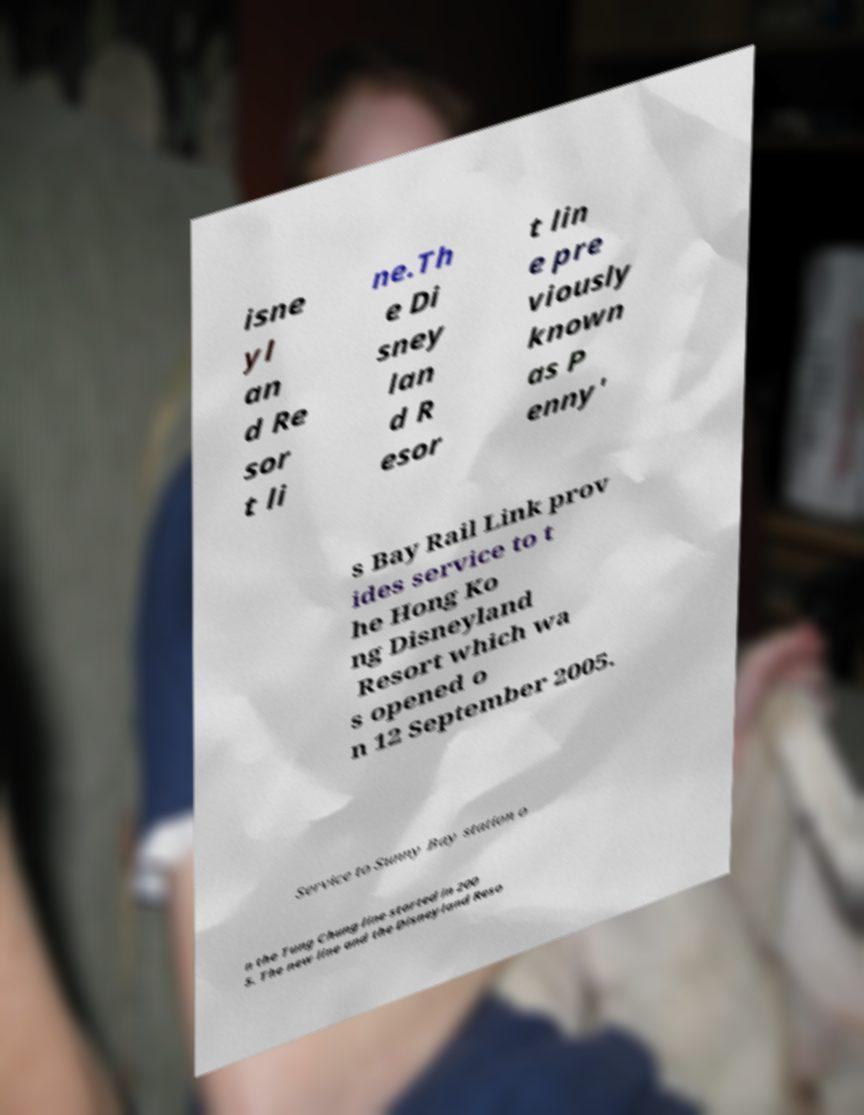Please read and relay the text visible in this image. What does it say? isne yl an d Re sor t li ne.Th e Di sney lan d R esor t lin e pre viously known as P enny' s Bay Rail Link prov ides service to t he Hong Ko ng Disneyland Resort which wa s opened o n 12 September 2005. Service to Sunny Bay station o n the Tung Chung line started in 200 5. The new line and the Disneyland Reso 